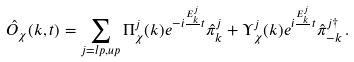Convert formula to latex. <formula><loc_0><loc_0><loc_500><loc_500>\hat { O } _ { \chi } ( { k } , t ) = \sum _ { j = l p , u p } \Pi ^ { j } _ { \chi } ( { k } ) e ^ { - i \frac { E _ { k } ^ { j } } { } t } \hat { \pi } ^ { j } _ { k } + \Upsilon ^ { j } _ { \chi } ( { k } ) e ^ { i \frac { E _ { k } ^ { j } } { } t } \hat { \pi } ^ { j \dagger } _ { - k } \, .</formula> 